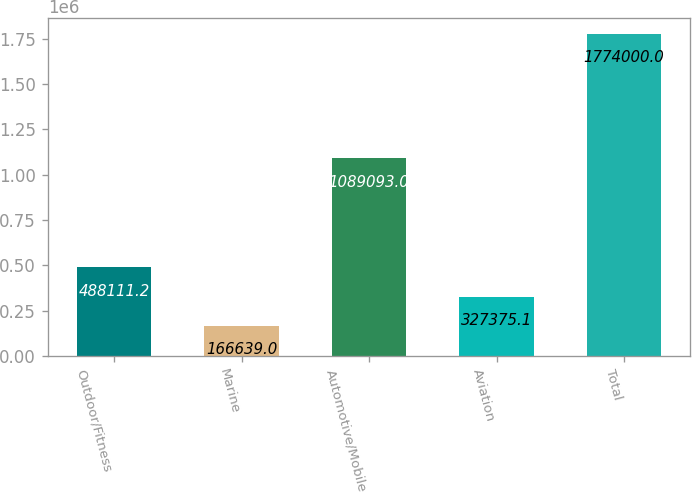Convert chart to OTSL. <chart><loc_0><loc_0><loc_500><loc_500><bar_chart><fcel>Outdoor/Fitness<fcel>Marine<fcel>Automotive/Mobile<fcel>Aviation<fcel>Total<nl><fcel>488111<fcel>166639<fcel>1.08909e+06<fcel>327375<fcel>1.774e+06<nl></chart> 